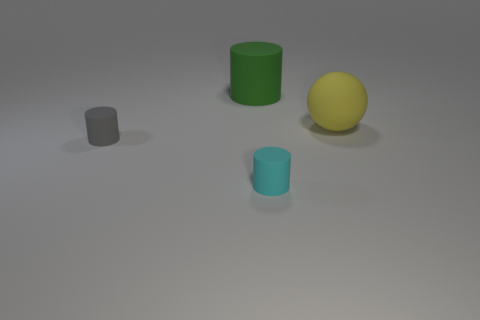Subtract all cyan cylinders. How many cylinders are left? 2 Subtract all spheres. How many objects are left? 3 Add 4 yellow balls. How many objects exist? 8 Subtract 1 balls. How many balls are left? 0 Subtract all cyan cylinders. Subtract all cyan balls. How many cylinders are left? 2 Subtract all tiny gray cylinders. Subtract all red matte balls. How many objects are left? 3 Add 2 large yellow balls. How many large yellow balls are left? 3 Add 1 big yellow cubes. How many big yellow cubes exist? 1 Subtract 0 purple cubes. How many objects are left? 4 